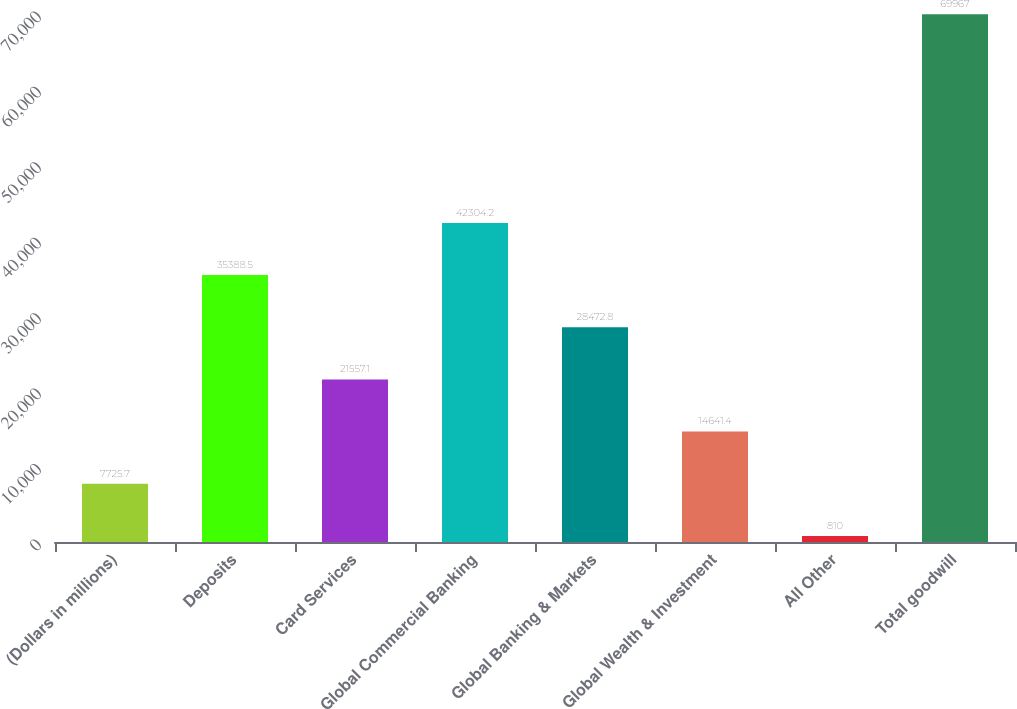Convert chart. <chart><loc_0><loc_0><loc_500><loc_500><bar_chart><fcel>(Dollars in millions)<fcel>Deposits<fcel>Card Services<fcel>Global Commercial Banking<fcel>Global Banking & Markets<fcel>Global Wealth & Investment<fcel>All Other<fcel>Total goodwill<nl><fcel>7725.7<fcel>35388.5<fcel>21557.1<fcel>42304.2<fcel>28472.8<fcel>14641.4<fcel>810<fcel>69967<nl></chart> 